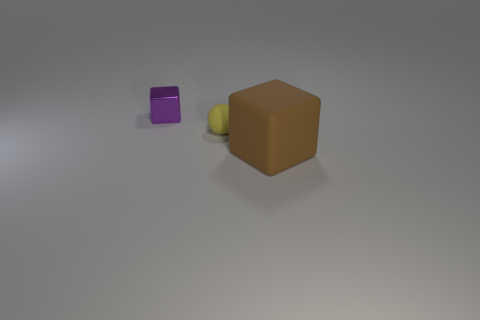Add 2 purple shiny objects. How many objects exist? 5 Subtract all cubes. How many objects are left? 1 Subtract all purple shiny things. Subtract all tiny yellow spheres. How many objects are left? 1 Add 2 small rubber spheres. How many small rubber spheres are left? 3 Add 2 tiny brown shiny blocks. How many tiny brown shiny blocks exist? 2 Subtract 0 blue cubes. How many objects are left? 3 